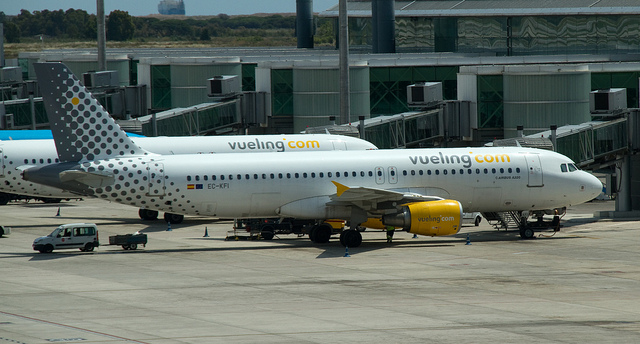Read and extract the text from this image. vuline com vueline com 